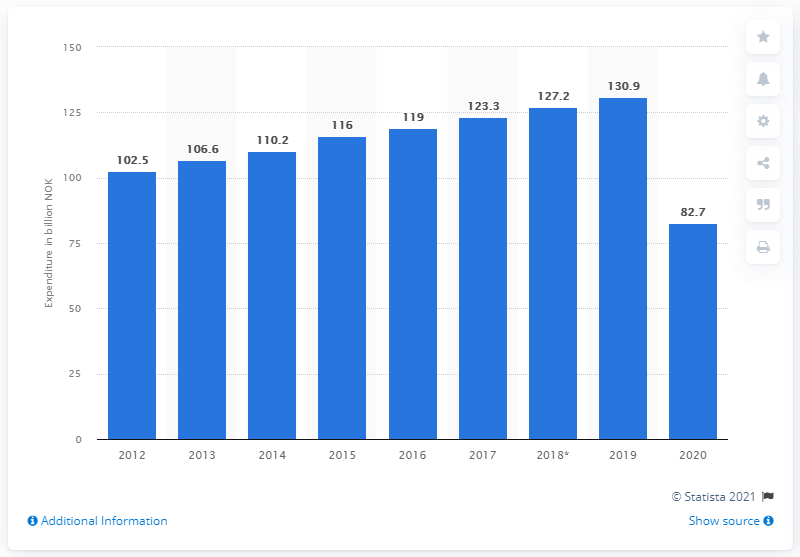Point out several critical features in this image. In 2020, the domestic tourism expenditure in Norway was 82.7 billion Norwegian kroner. In 2019, Norwegian residents spent a total of 130.9 billion kroner on domestic tourism. 